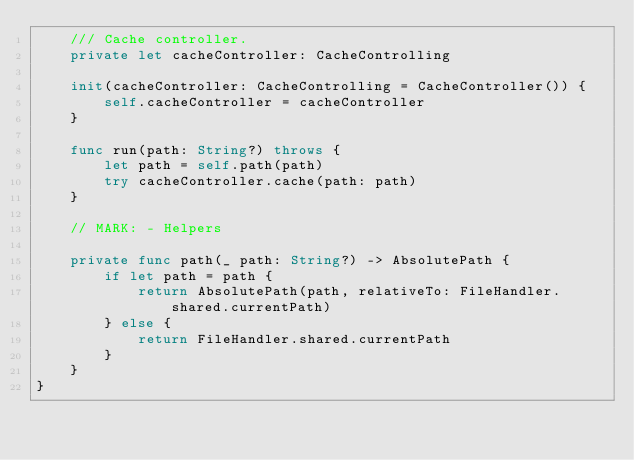Convert code to text. <code><loc_0><loc_0><loc_500><loc_500><_Swift_>    /// Cache controller.
    private let cacheController: CacheControlling

    init(cacheController: CacheControlling = CacheController()) {
        self.cacheController = cacheController
    }

    func run(path: String?) throws {
        let path = self.path(path)
        try cacheController.cache(path: path)
    }

    // MARK: - Helpers

    private func path(_ path: String?) -> AbsolutePath {
        if let path = path {
            return AbsolutePath(path, relativeTo: FileHandler.shared.currentPath)
        } else {
            return FileHandler.shared.currentPath
        }
    }
}
</code> 